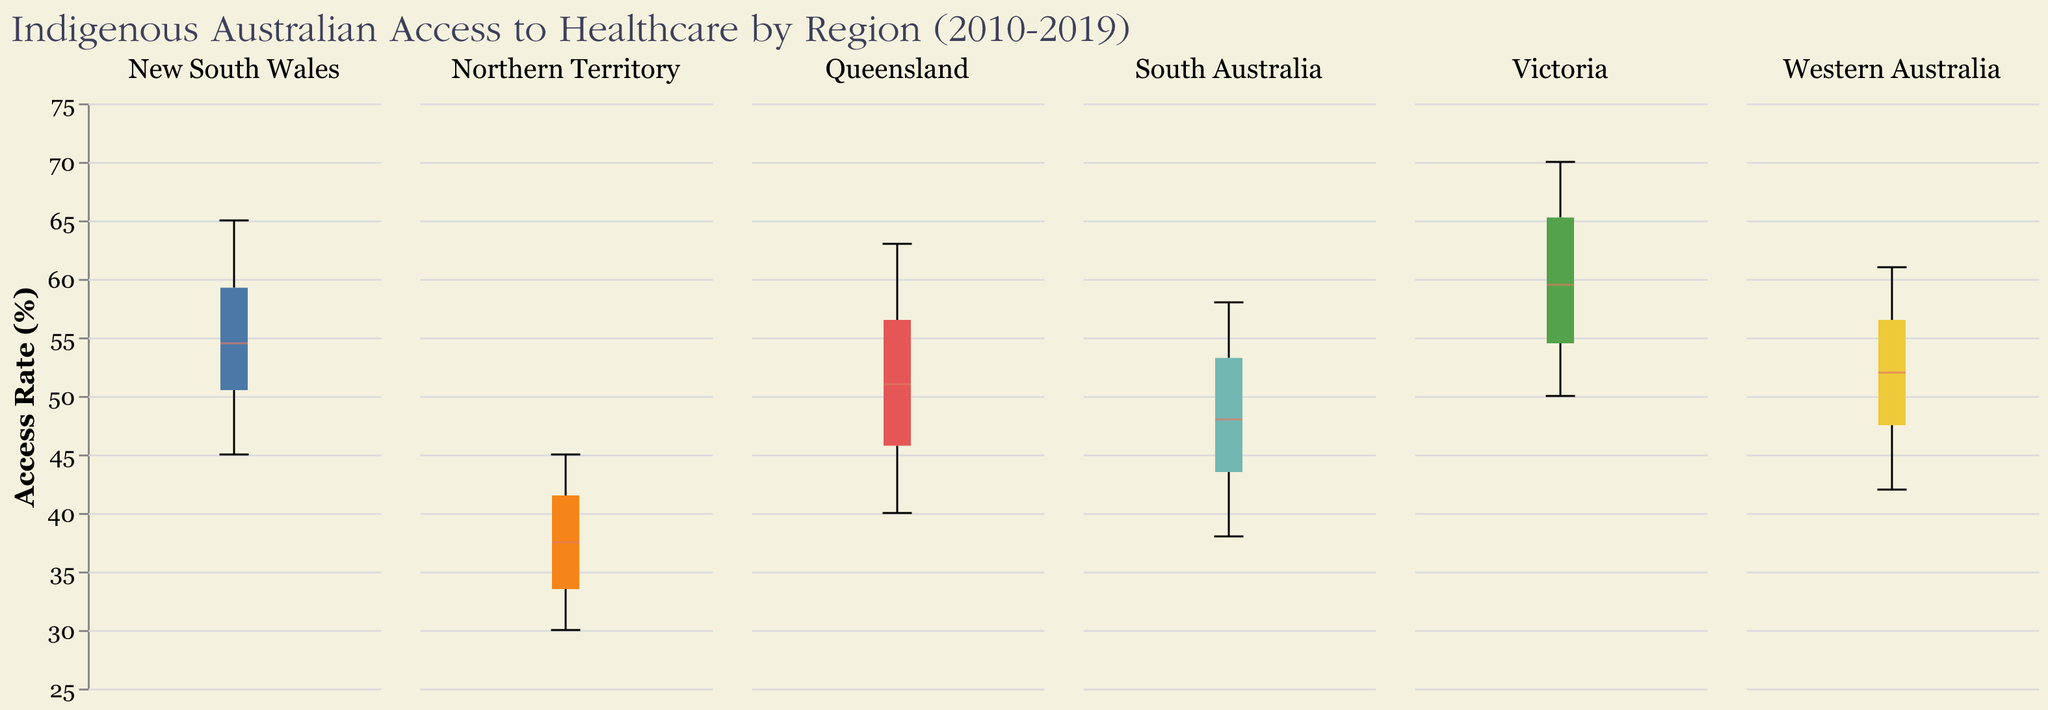What is the median access rate for New South Wales over the years shown? The figure shows a box plot with different regions and their access rates over the years. You need to look at the box plot for New South Wales and identify the median line, which is typically marked within the box.
Answer: 54.5 Which region had the highest increase in access rates from 2010 to 2019? By observing the box plots, you can determine the region with the largest difference between the access rate at the beginning (2010) and the end (2019) of the time range. Look for the region where the topmost marks indicate a significant increase over the years.
Answer: Victoria What is the interquartile range (IQR) for Queensland? The IQR is the range between the first quartile (Q1) and the third quartile (Q3), represented by the lower and upper edges of the box. For Queensland, visually locate these edges on the box plot and subtract the value at Q1 from the value at Q3.
Answer: 12 (from 48 to 60) Which region shows the least variability in access rates over the decade? The region with the smallest IQR (the height of the box in the box plot) represents the least variability. Compare the heights of the boxes for each region to find the smallest one.
Answer: Victoria Does any region show an access rate that falls below 35% in 2019? To answer this, locate the ends of the whiskers for each region in the 2019 box plot and check if any of them fall below the 35% mark.
Answer: No Which region’s median access rate remained consistently higher than 50% throughout the decade? Look at the median lines in the box plots across the regions and over the years. Identify the region whose median line is consistently above 50% every year.
Answer: Victoria How does the access rate for Northern Territory in 2010 compare to Western Australia in the same year? Observe the position of the 2010 data points in the box plots for both Northern Territory and Western Australia. Comparing these values directly gives the answer.
Answer: Northern Territory is lower at 30%, whereas Western Australia is 42% What is the general trend in access rates for all regions from 2010 to 2019? Examine the box plots to identify if there's a general upward, downward, or stable trend in access rates over the years across all regions.
Answer: Upward trend Which two regions have the closest median access rates in 2019? Check the median lines for each region's box plot in 2019 and find the two regions with the median lines closest to each other.
Answer: Queensland and Western Australia What year marks the first time New South Wales's access rate reaches or exceeds 60%? Look at the data points or the whiskers/boxes for New South Wales year-wise. Observe in which year the access rate first reaches or exceeds the 60% mark.
Answer: 2017 